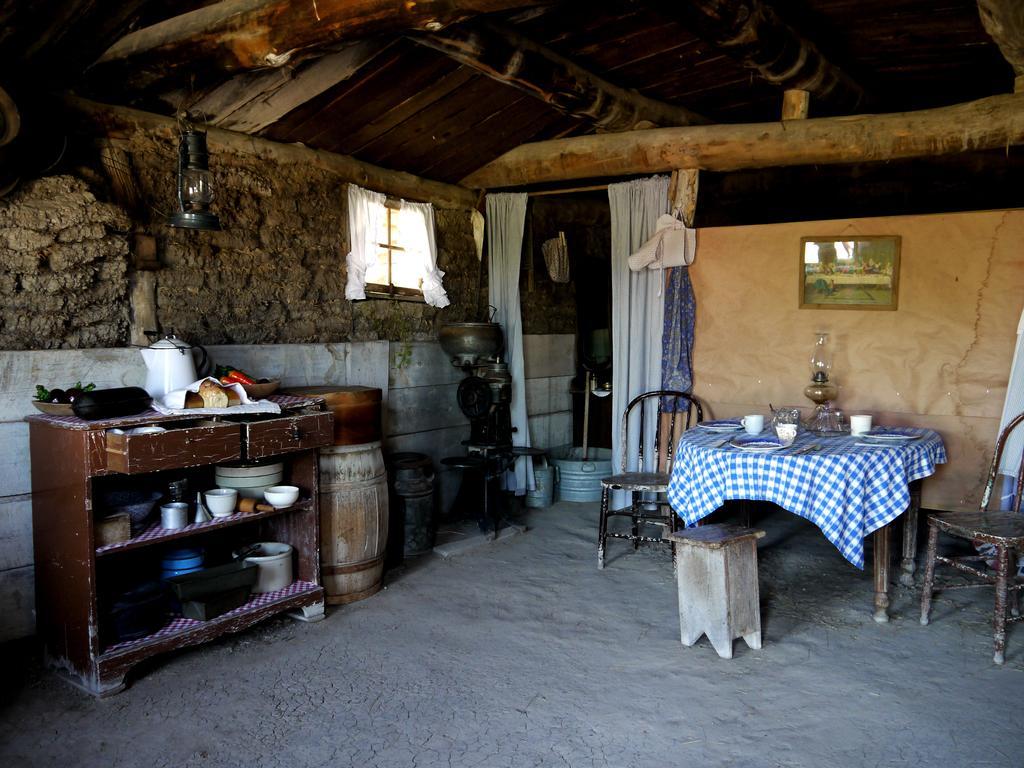Can you describe this image briefly? There is a table and chairs on the right side. There is a glass,plate,lamp on a table. There is a cupboard on the right side. There is a bowls and jars on a table. We can see in the background wall,wooden stick,curtain and photo frame. 